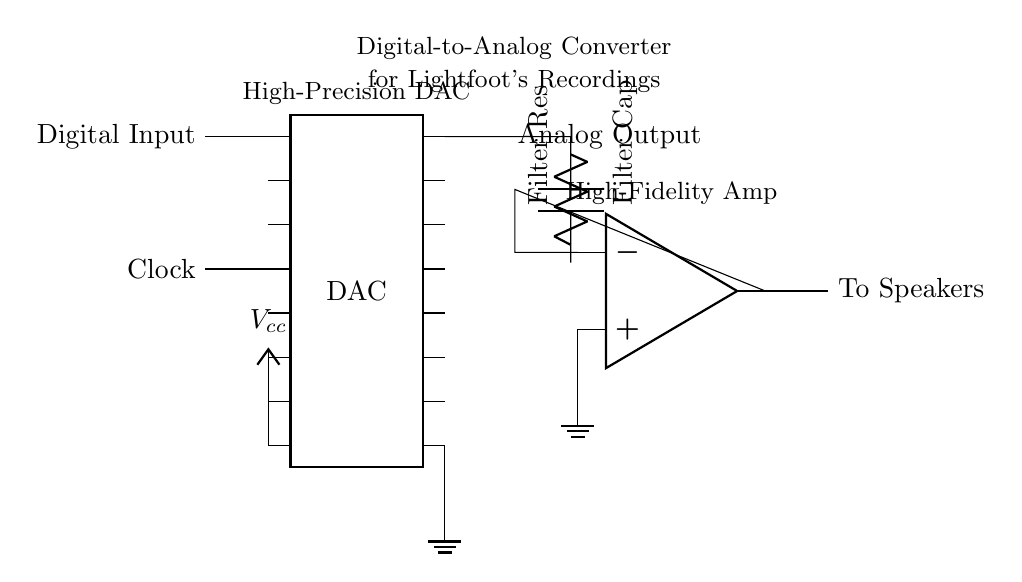What is the component labeled as DAC? The component labeled as DAC is a Digital-to-Analog Converter, which is responsible for converting digital signals into analog signals for audio playback.
Answer: Digital-to-Analog Converter How many pins does the DAC have? The DAC has a total of 16 pins as indicated in the diagram showing a dip chip with 16 pin positions.
Answer: 16 What is the purpose of the low-pass filter in this circuit? The low-pass filter, consisting of a capacitor and resistor, is intended to remove high-frequency noise from the signal coming from the DAC, ensuring that the analog output is smooth and clean for better sound quality.
Answer: Remove high-frequency noise What type of amplifier is used in this circuit? The amplifier used in this circuit is an operational amplifier, which is commonly used to amplify audio signals for higher fidelity playback.
Answer: Operational amplifier What is the voltage labeled as Vcc? The voltage labeled as Vcc is the power supply voltage for the DAC, typically providing the necessary power for its operation in the circuit.
Answer: Power supply voltage What connects the DAC output to the speakers? The output from the DAC connects to the speakers through the operational amplifier stage, which further amplifies the analog signal before sending it to the speakers.
Answer: Operational amplifier stage What type of clock is mentioned in the circuit? The clock specified in the circuit is a timing signal that synchronizes the digital input to the DAC, ensuring accurate conversion from digital to analog signals at the correct intervals.
Answer: Timing signal 